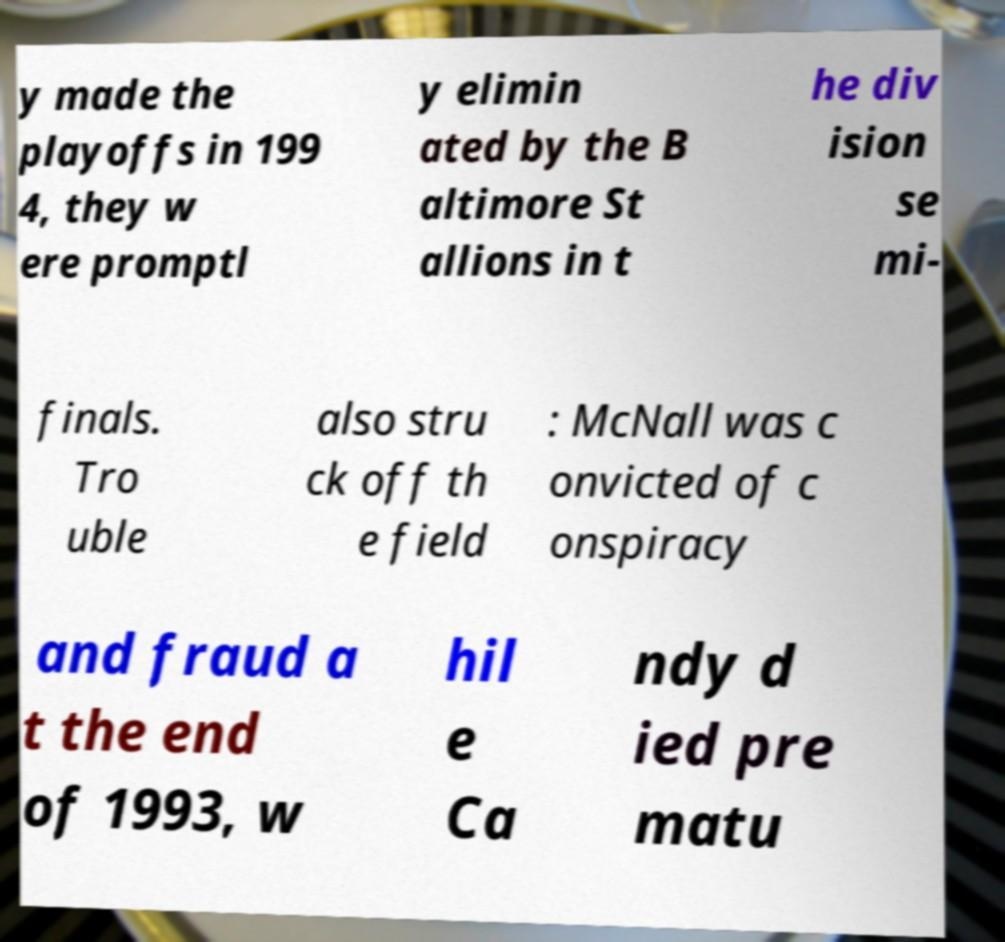What messages or text are displayed in this image? I need them in a readable, typed format. y made the playoffs in 199 4, they w ere promptl y elimin ated by the B altimore St allions in t he div ision se mi- finals. Tro uble also stru ck off th e field : McNall was c onvicted of c onspiracy and fraud a t the end of 1993, w hil e Ca ndy d ied pre matu 